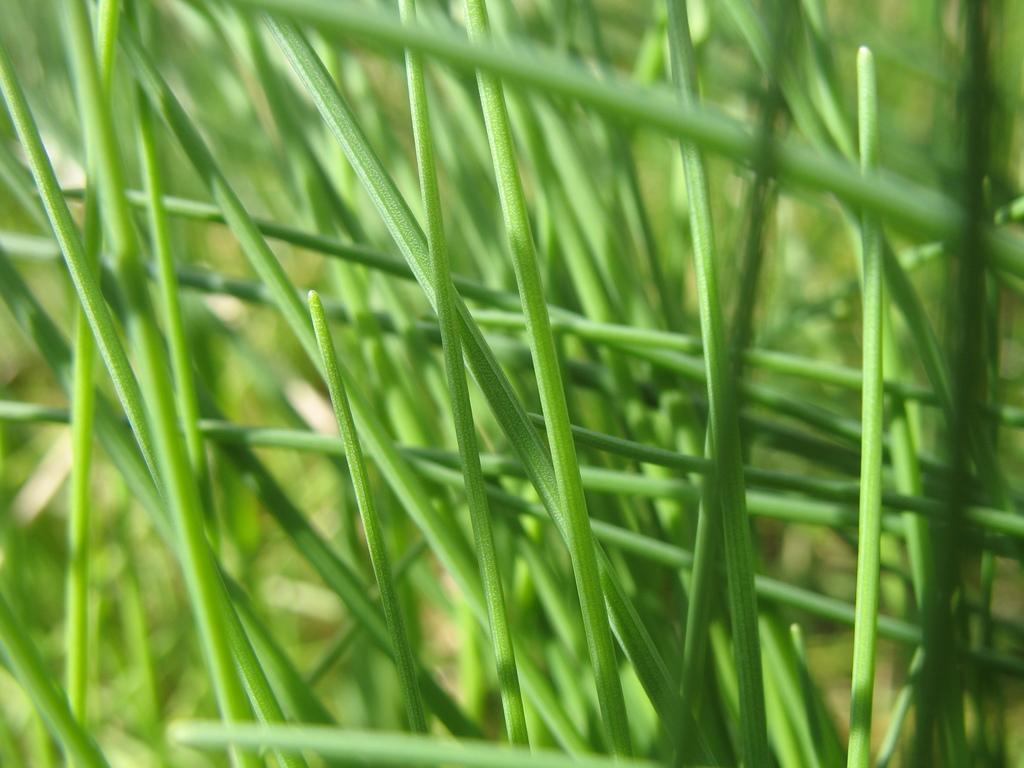Please provide a concise description of this image. In the picture we can see a grass plants which are green in color. 